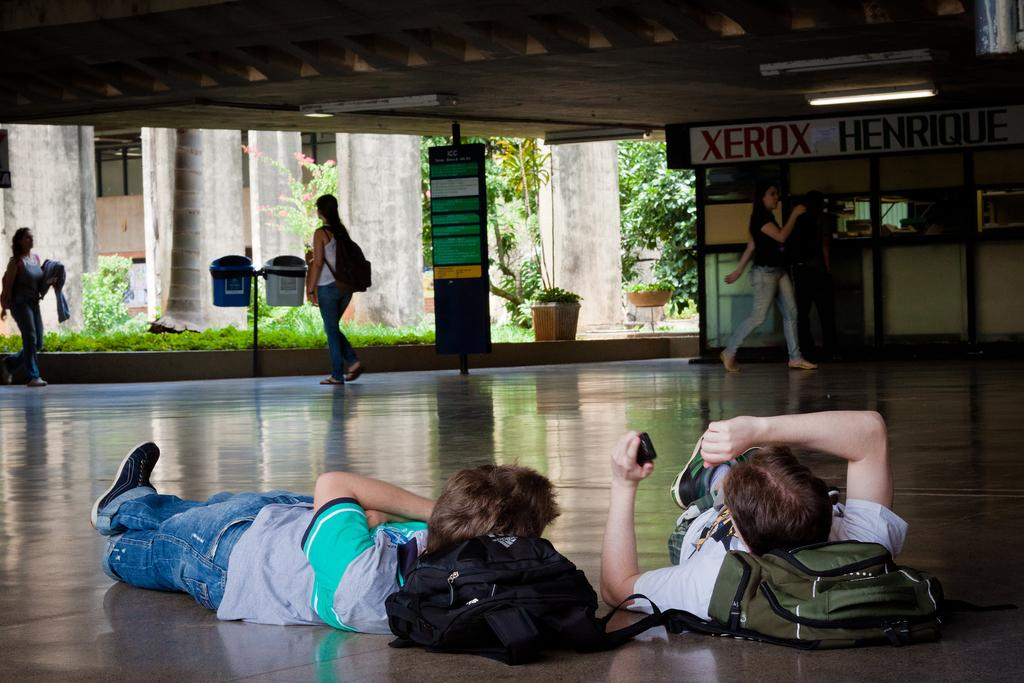<image>
Present a compact description of the photo's key features. Two kids lie on the floor as people walk past a Xerox office. 